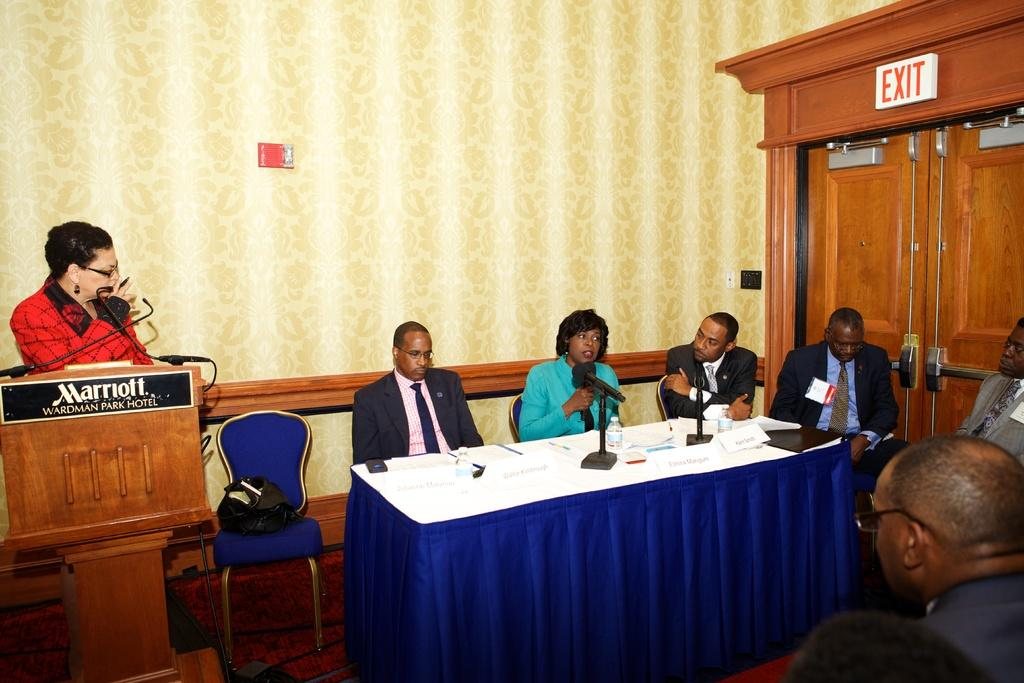What type of flooring is visible in the image? There are tiles in the image. What are the people in the image doing? The people are sitting on chairs in the image. What piece of furniture is present in the image? There is a table in the image. What is on the table in the image? There are mice and papers on the table in the image. What type of jam is being spread on the head of the person in the image? There is no jam or person having their head spread with jam in the image. How is the hose connected to the table in the image? There is no hose present in the image. 